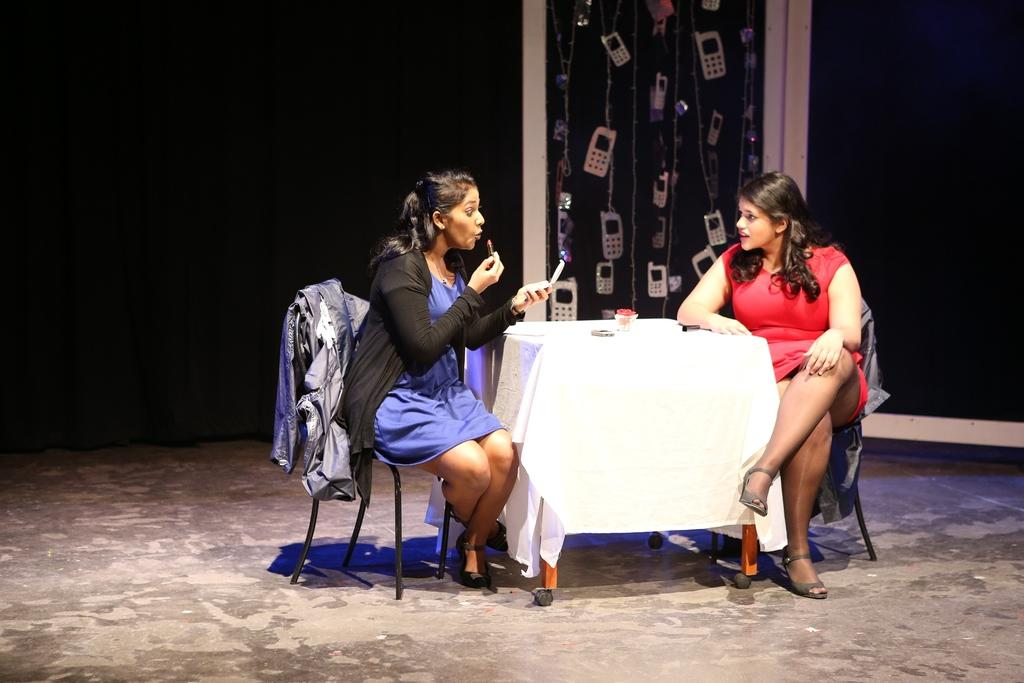How many people are in the image? There are two women in the image. What are the women doing in the image? The women are sitting in chairs on either side of a table and talking. What can be inferred about the lighting in the image? The background of the image appears to be dark. What type of oven can be seen in the image? There is no oven present in the image. How many cars are visible in the image? There are no cars visible in the image. 